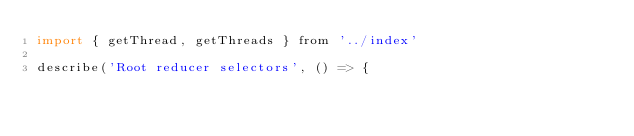Convert code to text. <code><loc_0><loc_0><loc_500><loc_500><_JavaScript_>import { getThread, getThreads } from '../index'

describe('Root reducer selectors', () => {</code> 